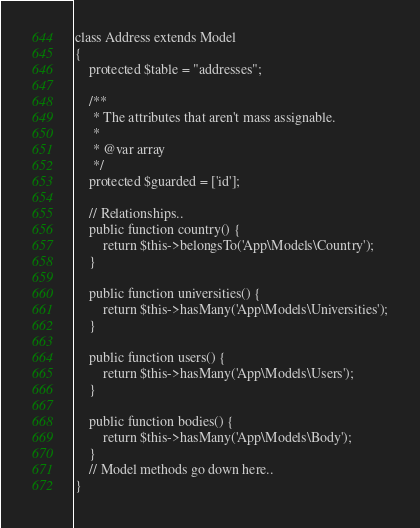<code> <loc_0><loc_0><loc_500><loc_500><_PHP_>class Address extends Model
{
    protected $table = "addresses";

    /**
     * The attributes that aren't mass assignable.
     *
     * @var array
     */
    protected $guarded = ['id'];

    // Relationships..
    public function country() {
    	return $this->belongsTo('App\Models\Country');
    }

    public function universities() {
    	return $this->hasMany('App\Models\Universities');
    }

    public function users() {
    	return $this->hasMany('App\Models\Users');
    }

    public function bodies() {
    	return $this->hasMany('App\Models\Body');
    }
    // Model methods go down here..
}
</code> 